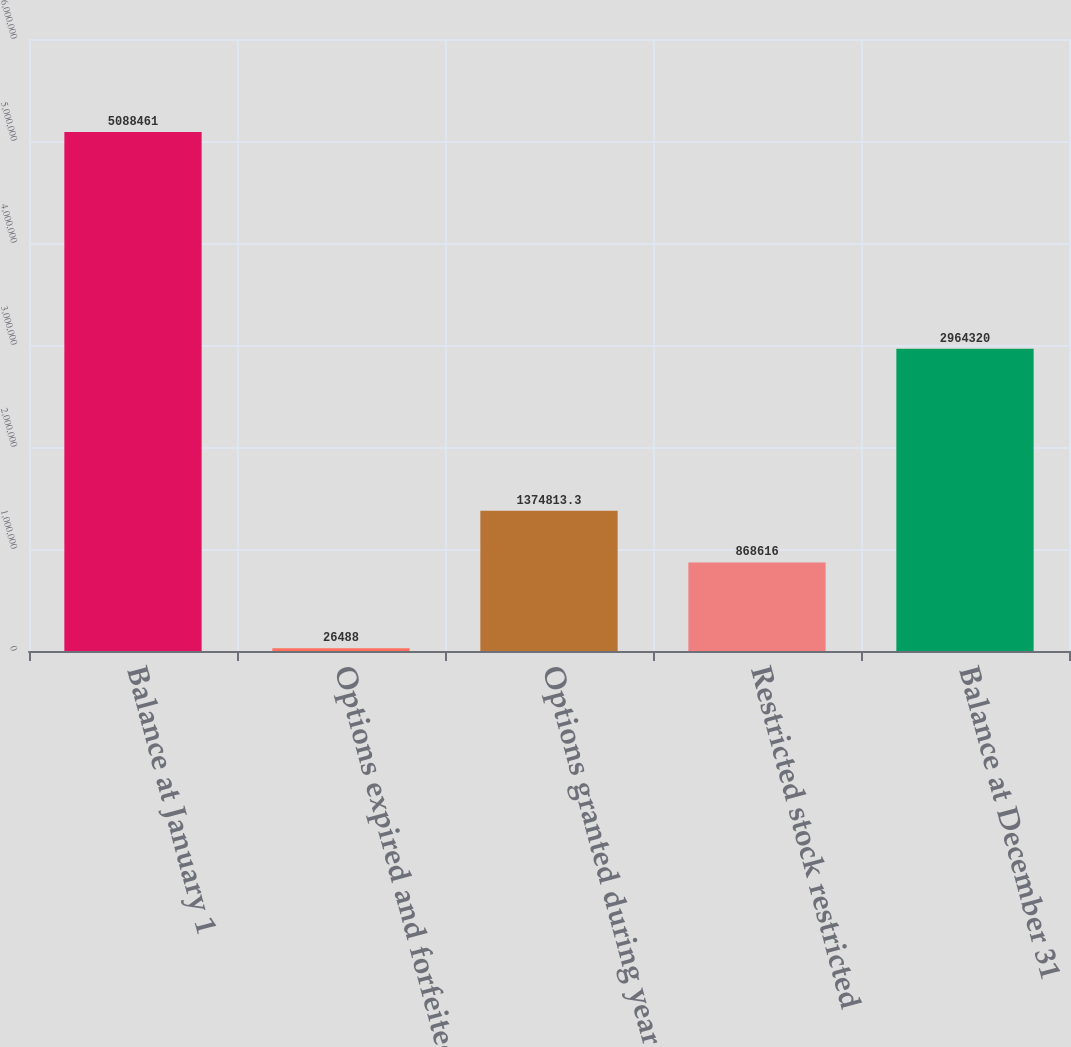<chart> <loc_0><loc_0><loc_500><loc_500><bar_chart><fcel>Balance at January 1<fcel>Options expired and forfeited<fcel>Options granted during year<fcel>Restricted stock restricted<fcel>Balance at December 31<nl><fcel>5.08846e+06<fcel>26488<fcel>1.37481e+06<fcel>868616<fcel>2.96432e+06<nl></chart> 